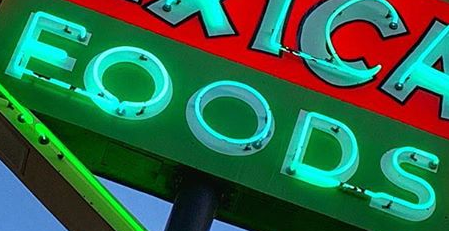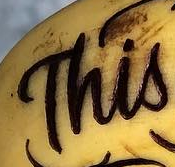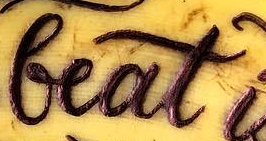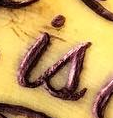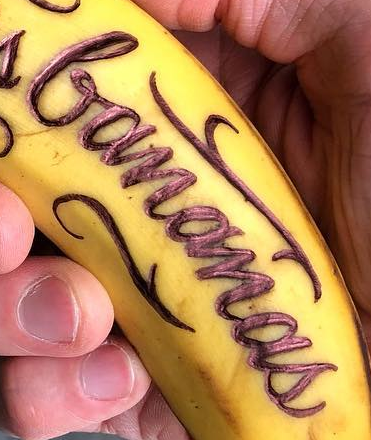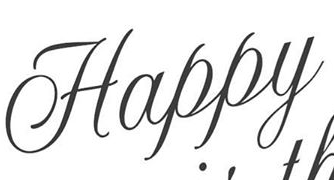What text appears in these images from left to right, separated by a semicolon? FOODS; This; beat; is; bananas; Happy 